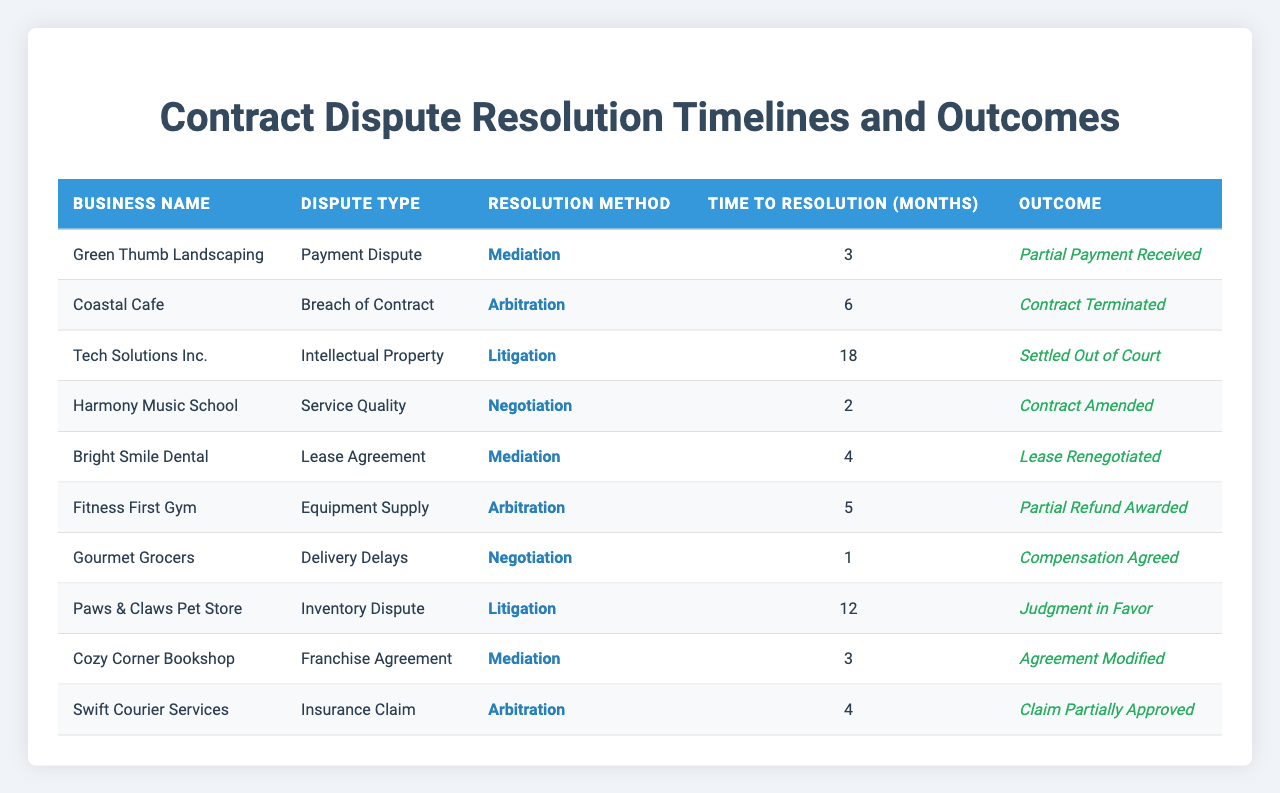What is the total time taken to resolve all disputes listed in the table? To calculate the total time, sum the "Time to Resolution (months)" column for all entries: 3 + 6 + 18 + 2 + 4 + 5 + 1 + 12 + 3 + 4 = 58 months.
Answer: 58 months Which business had the quickest dispute resolution? The "Time to Resolution (months)" column shows that "Gourmet Grocers" resolved their dispute in 1 month, which is the lowest value in the column.
Answer: Gourmet Grocers How many businesses achieved a favorable outcome? A favorable outcome can be defined as any resolution that is a modification or an award. The rows corresponding to "Harmony Music School," "Bright Smile Dental," "Gourmet Grocers," "Cozy Corner Bookshop," and "Fitness First Gym" show favorable outcomes. Counting these gives a total of 5 businesses.
Answer: 5 What was the average time to resolution for disputes resolved through mediation? Filter the entries to find those with "Mediation" as the resolution method: 3 (Green Thumb Landscaping) + 4 (Bright Smile Dental) + 3 (Cozy Corner Bookshop) = 10 months. There are 3 such cases, so the average is 10/3 = approximately 3.33 months.
Answer: Approximately 3.33 months Did any business achieve a full resolution without partial payments or terminations? The outcome for "Harmony Music School," "Bright Smile Dental," "Gourmet Grocers," and "Cozy Corner Bookshop" shows successful modifications or agreements without terminations or partial payments. This counts as 4.
Answer: Yes What type of disputes took the longest to resolve and what was that duration? The longest time listed in the "Time to Resolution (months)" column is 18 months for "Tech Solutions Inc." regarding an "Intellectual Property" dispute.
Answer: 18 months How many businesses used litigation as a resolution method and what were their outcomes? There are 3 entries with "Litigation": "Tech Solutions Inc." (Settled Out of Court), "Paws & Claws Pet Store" (Judgment in Favor), totaling 2 positive outcomes.
Answer: 3 businesses Which resolution method had the highest average time to resolution? Calculating averages for each method reveals: Mediation (3.33), Arbitration (5), Negotiation (2), Litigation (15). Thus, Litigation has the highest average time at 15 months.
Answer: Litigation What percentage of disputes resolved through arbitration resulted in a partial or full approval? There are 3 disputes using arbitration: "Coastal Cafe" (Contract Terminated), "Fitness First Gym" (Partial Refund Awarded), and "Swift Courier Services" (Claim Partially Approved). Only 2 resulted in partial or full approval, so the percentage is (2/3)*100 = 66.67%.
Answer: 66.67% Did “Tech Solutions Inc.” experience the longest overall resolution period and what was the dispute type? Yes, "Tech Solutions Inc." took 18 months, the longest listed, for an "Intellectual Property" dispute.
Answer: Yes 